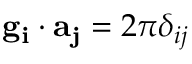<formula> <loc_0><loc_0><loc_500><loc_500>g _ { i } \cdot a _ { j } = 2 \pi \delta _ { i j }</formula> 